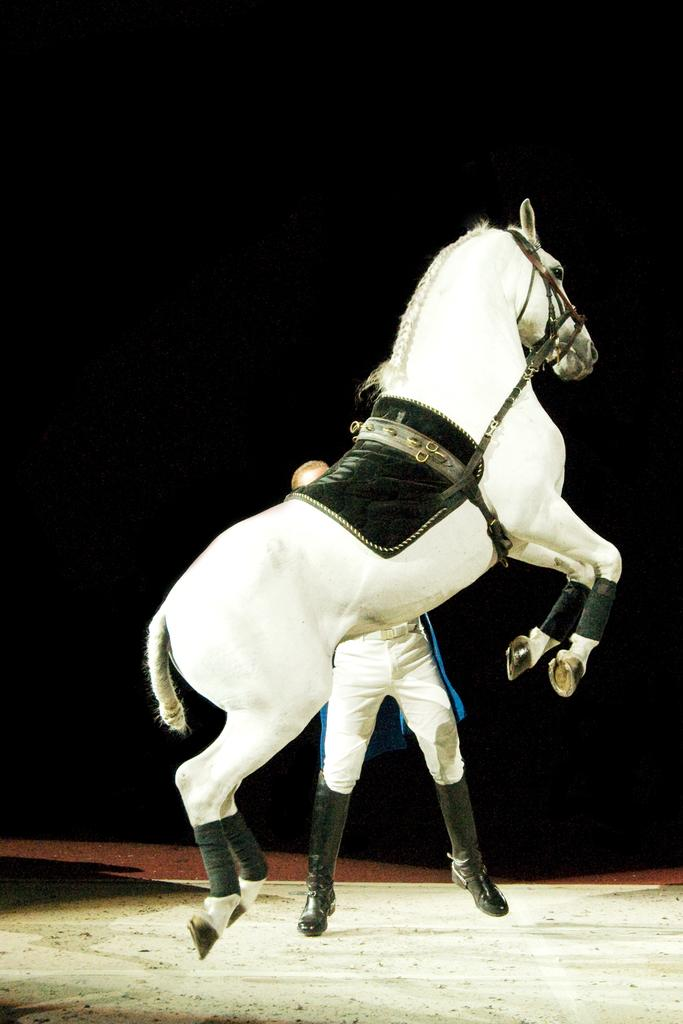What animal is present in the image? There is a horse in the image. Can you describe the color of the horse? The horse is white. What else can be seen in the image besides the horse? There is a person in the image. What is the person wearing? The person is wearing a white dress. How would you describe the overall lighting or color of the background in the image? The background of the image is dark. Who is the owner of the school in the image? There is no school present in the image, so it is not possible to determine the owner. What type of brick is used to build the horse in the image? The horse in the image is a real animal, not a brick structure, so there is no brick used to build it. 